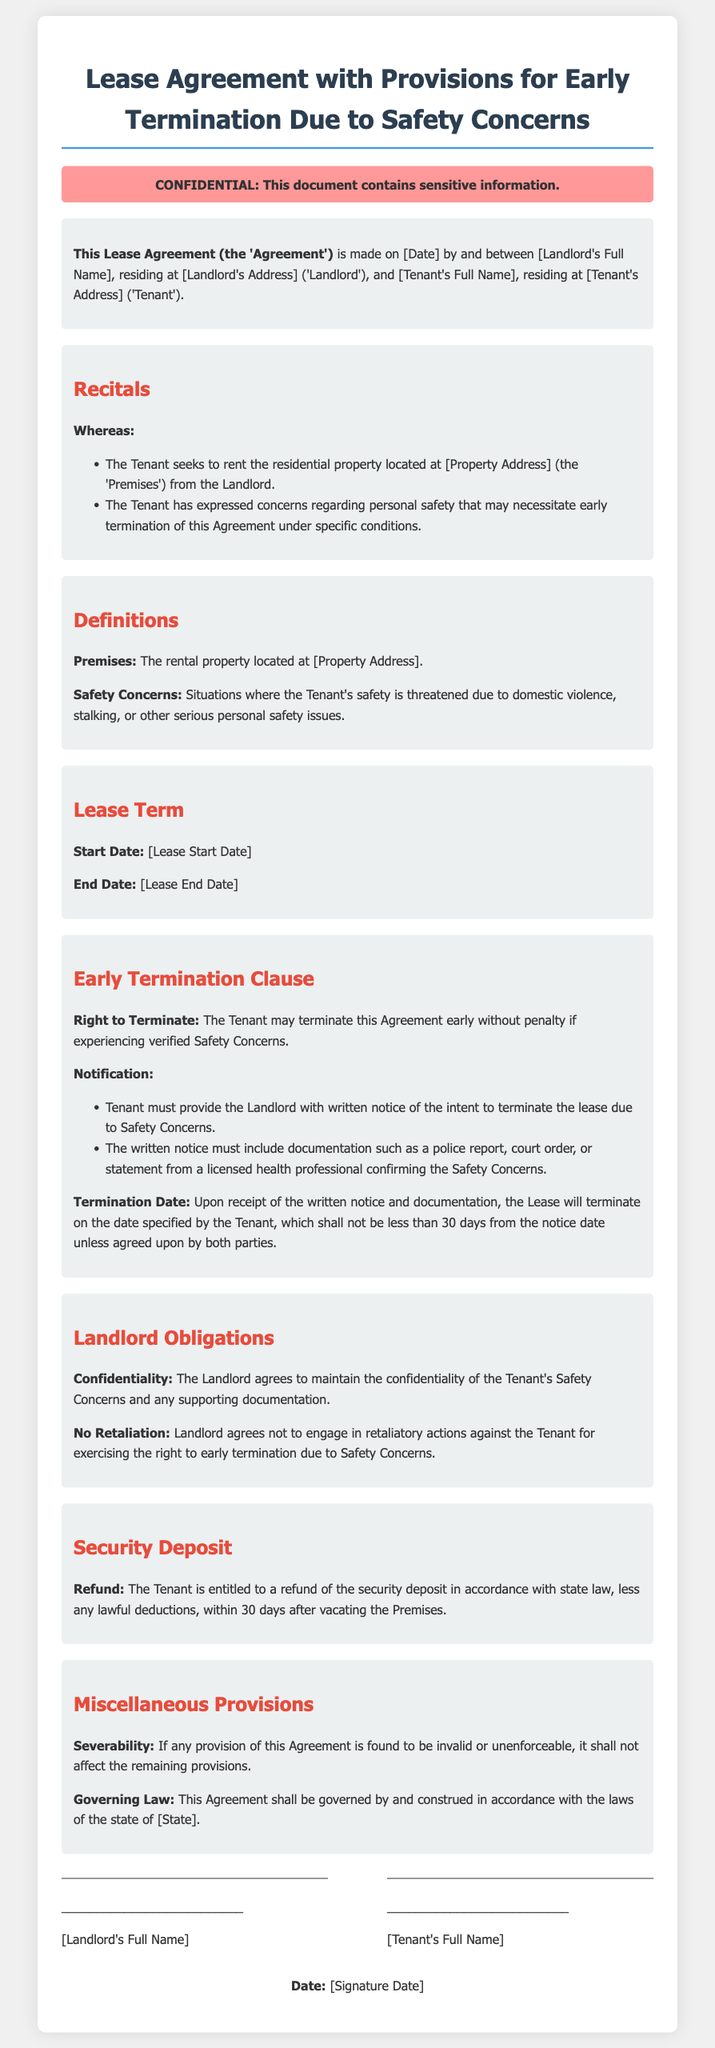What is the title of the document? The title of the document is indicated at the top of the rendered contract.
Answer: Lease Agreement with Provisions for Early Termination Due to Safety Concerns Who are the parties involved in the agreement? The parties involved are identified in the introduction section of the contract.
Answer: Landlord and Tenant What is the duration of the lease? The duration of the lease is mentioned in the Lease Term section of the document.
Answer: [Lease Start Date] to [Lease End Date] What documentation must the Tenant provide to terminate the lease? The required documentation is specified in the Early Termination Clause under Notification.
Answer: Police report, court order, or statement from a licensed health professional How many days notice must the Tenant give for termination? The notice period for termination is outlined in the Early Termination Clause.
Answer: 30 days What agreement does the Landlord make regarding confidentiality? The Landlord's obligation regarding confidentiality is stated in the Landlord Obligations section.
Answer: Maintain the confidentiality of the Tenant's Safety Concerns What must occur upon the Tenant providing written notice? The action that follows will occur as stated in the Early Termination Clause.
Answer: The Lease will terminate on the date specified by the Tenant What law governs this Agreement? The governing law of the agreement is described in the Miscellaneous Provisions section.
Answer: [State] 